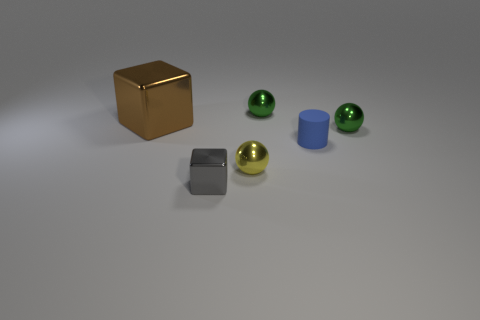There is a metallic block behind the gray metal block; is its color the same as the tiny matte object?
Make the answer very short. No. What number of things are small cylinders or metal cubes behind the gray object?
Ensure brevity in your answer.  2. There is a thing that is both left of the tiny yellow metallic object and in front of the tiny rubber cylinder; what is it made of?
Give a very brief answer. Metal. What is the small object that is to the left of the yellow metal thing made of?
Provide a short and direct response. Metal. There is a big thing that is the same material as the tiny yellow ball; what is its color?
Your response must be concise. Brown. Do the blue object and the tiny object behind the large metallic block have the same shape?
Offer a very short reply. No. Are there any small gray cubes behind the brown thing?
Ensure brevity in your answer.  No. Is the size of the brown cube the same as the metallic sphere that is to the right of the rubber cylinder?
Your answer should be compact. No. Is there a shiny sphere that has the same color as the big cube?
Offer a terse response. No. Is there a small green thing of the same shape as the small gray metal object?
Make the answer very short. No. 